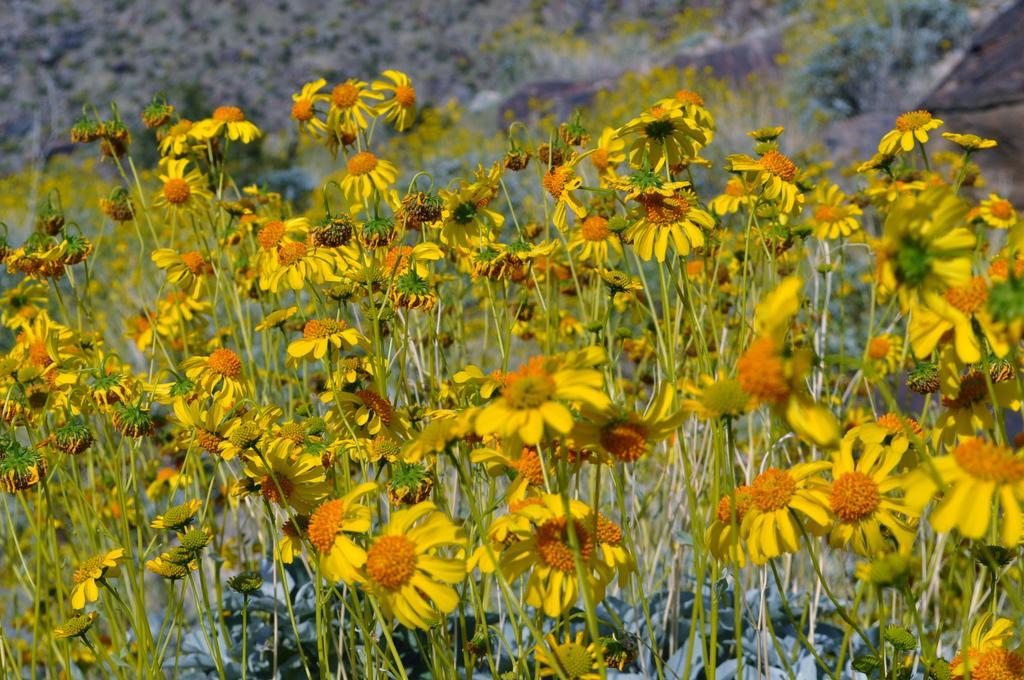In one or two sentences, can you explain what this image depicts? In this picture I can see plants with yellow flowers, and there is blur background. 